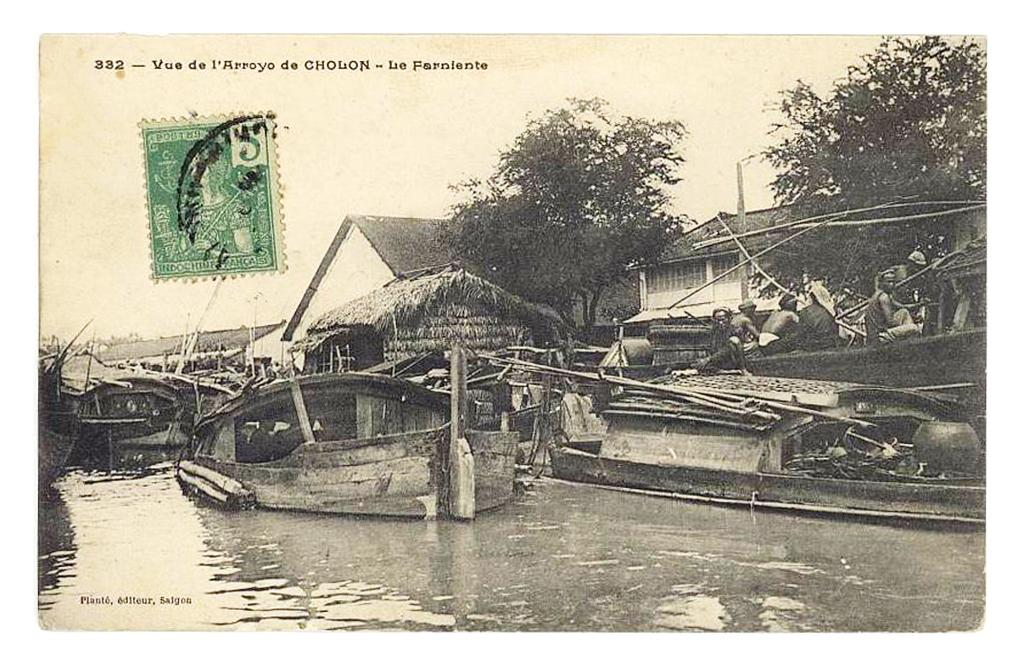What is depicted on the paper in the image? The paper contains a drawing of a boat. What elements are included in the drawing of the boat? The drawing includes water, houses, trees, and a sky. How many geese are flying in the sky in the drawing? There are no geese present in the drawing; it only includes a sky. Is the kite flying in the drawing? There is no kite present in the drawing; it only includes a boat, water, houses, trees, and a sky. 